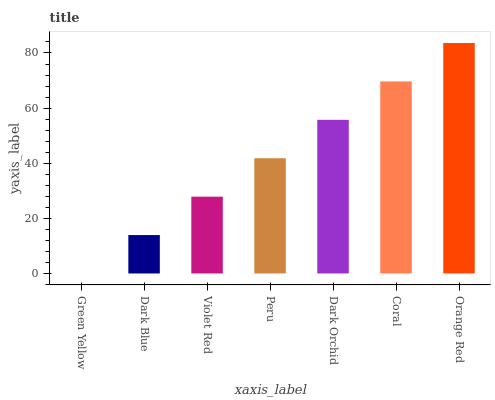Is Dark Blue the minimum?
Answer yes or no. No. Is Dark Blue the maximum?
Answer yes or no. No. Is Dark Blue greater than Green Yellow?
Answer yes or no. Yes. Is Green Yellow less than Dark Blue?
Answer yes or no. Yes. Is Green Yellow greater than Dark Blue?
Answer yes or no. No. Is Dark Blue less than Green Yellow?
Answer yes or no. No. Is Peru the high median?
Answer yes or no. Yes. Is Peru the low median?
Answer yes or no. Yes. Is Dark Orchid the high median?
Answer yes or no. No. Is Coral the low median?
Answer yes or no. No. 